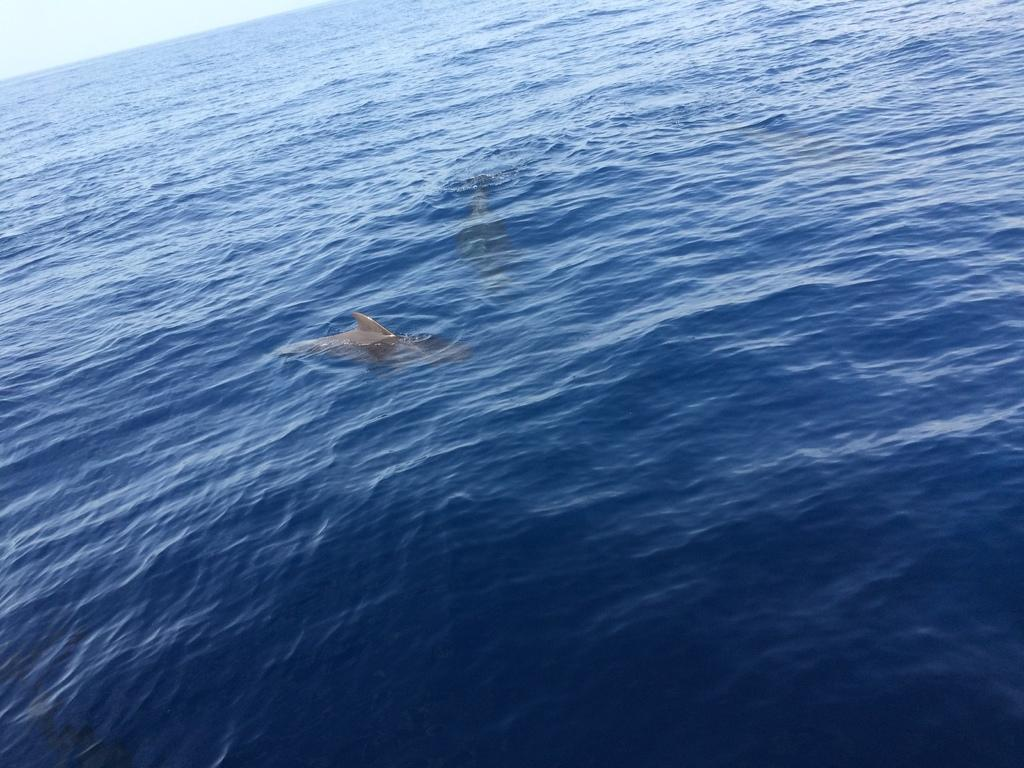What animals can be seen in the image? There are dolphins in the water. What part of the natural environment is visible in the image? The sky is visible in the background of the image. What type of sand can be seen on the dolphins in the image? There is no sand present in the image; it features dolphins in the water. What color is the stamp on the dolphin's fin in the image? There are no stamps present on the dolphins in the image. 